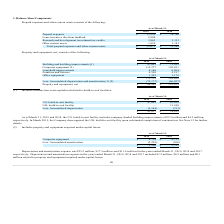According to Mimecast Limited's financial document, How much was Depreciation and amortization expense for the years ended March 31, 2019? According to the financial document, $25.2 million. The relevant text states: "Depreciation and amortization expense was $25.2 million, $17.5 million, and $11.8 million for the years ended March 31, 2019, 2018 and 2017,..." Also, How much was Depreciation and amortization expense for the years ended March 31, 2018? According to the financial document, $17.5 million. The relevant text states: "iation and amortization expense was $25.2 million, $17.5 million, and $11.8 million for the years ended March 31, 2019, 2018 and 2017,..." Also, How much was Depreciation and amortization expense for the years ended March 31, 2017? According to the financial document, $11.8 million. The relevant text states: "tion expense was $25.2 million, $17.5 million, and $11.8 million for the years ended March 31, 2019, 2018 and 2017,..." Also, can you calculate: What is the change in Computer equipment from March 31, 2018 to March 31, 2019? Based on the calculation: 4,754-4,713, the result is 41. This is based on the information: "Computer equipment $ 4,754 $ 4,713 Computer equipment $ 4,754 $ 4,713..." The key data points involved are: 4,713, 4,754. Also, can you calculate: What is the change in Accumulated amortization from March 31, 2018 to March 31, 2019? Based on the calculation: 2,228-990, the result is 1238. This is based on the information: "Less: Accumulated amortization (2,228) (990) Less: Accumulated amortization (2,228) (990)..." The key data points involved are: 2,228, 990. Also, can you calculate: What is the average Computer equipment for March 31, 2018 to March 31, 2019? To answer this question, I need to perform calculations using the financial data. The calculation is: (4,754+4,713) / 2, which equals 4733.5. This is based on the information: "Computer equipment $ 4,754 $ 4,713 Computer equipment $ 4,754 $ 4,713..." The key data points involved are: 4,713, 4,754. 